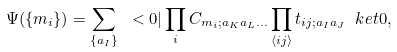<formula> <loc_0><loc_0><loc_500><loc_500>\Psi ( \{ m _ { i } \} ) = \sum _ { \{ a _ { I } \} } \ < 0 | \prod _ { i } C _ { m _ { i } ; a _ { K } a _ { L } \dots } \prod _ { \langle i j \rangle } t _ { i j ; a _ { I } a _ { J } } \ k e t { 0 } ,</formula> 